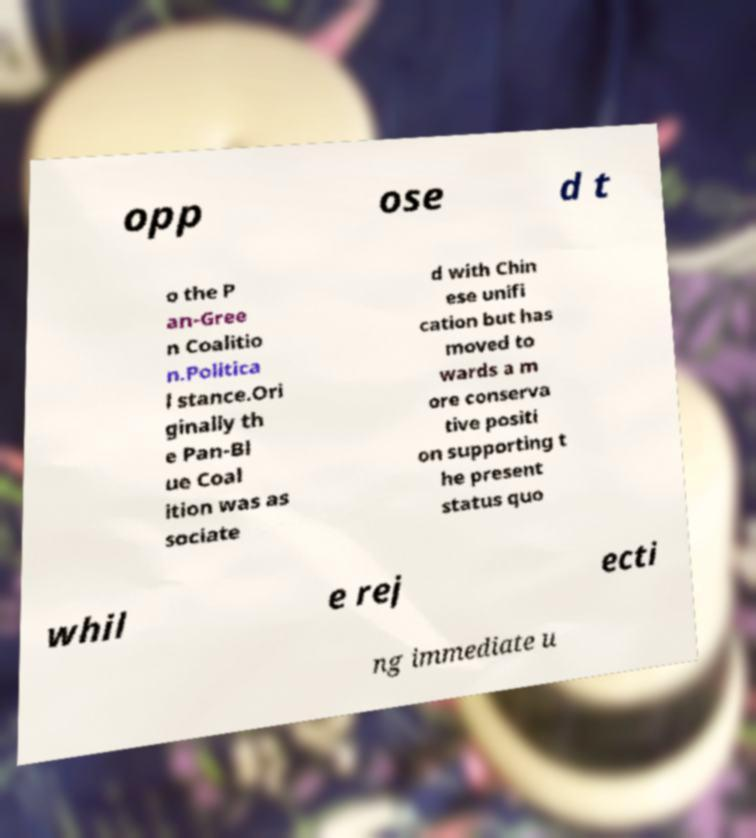Could you extract and type out the text from this image? opp ose d t o the P an-Gree n Coalitio n.Politica l stance.Ori ginally th e Pan-Bl ue Coal ition was as sociate d with Chin ese unifi cation but has moved to wards a m ore conserva tive positi on supporting t he present status quo whil e rej ecti ng immediate u 